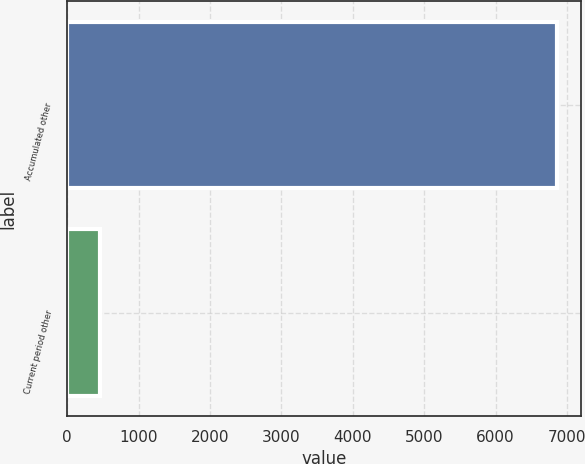Convert chart. <chart><loc_0><loc_0><loc_500><loc_500><bar_chart><fcel>Accumulated other<fcel>Current period other<nl><fcel>6855<fcel>458<nl></chart> 